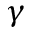Convert formula to latex. <formula><loc_0><loc_0><loc_500><loc_500>\gamma</formula> 